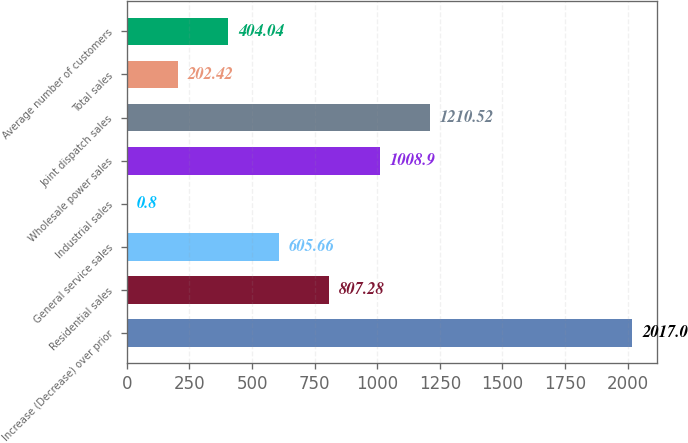Convert chart. <chart><loc_0><loc_0><loc_500><loc_500><bar_chart><fcel>Increase (Decrease) over prior<fcel>Residential sales<fcel>General service sales<fcel>Industrial sales<fcel>Wholesale power sales<fcel>Joint dispatch sales<fcel>Total sales<fcel>Average number of customers<nl><fcel>2017<fcel>807.28<fcel>605.66<fcel>0.8<fcel>1008.9<fcel>1210.52<fcel>202.42<fcel>404.04<nl></chart> 